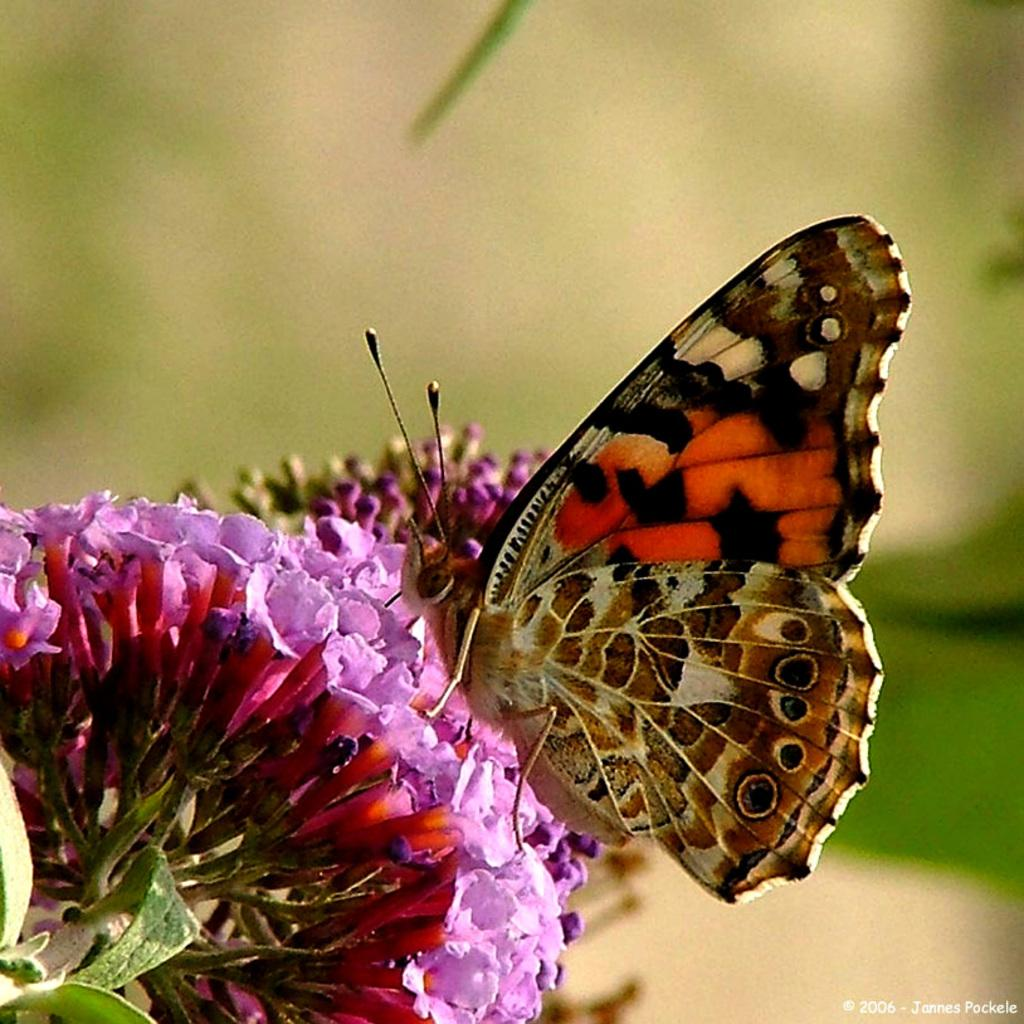How many bunches of flowers can be seen in the image? There are two bunches of flowers in the image. What is the location of the butterfly in the image? The butterfly is sitting on one of the bunches of flowers in the image. Can you describe the plant in the image? Unfortunately, the facts provided do not mention any specific details about the plant in the image. What type of cherries can be seen hanging from the plant in the image? There is no mention of cherries or a plant with cherries in the provided facts. The image only features two bunches of flowers and a butterfly. 